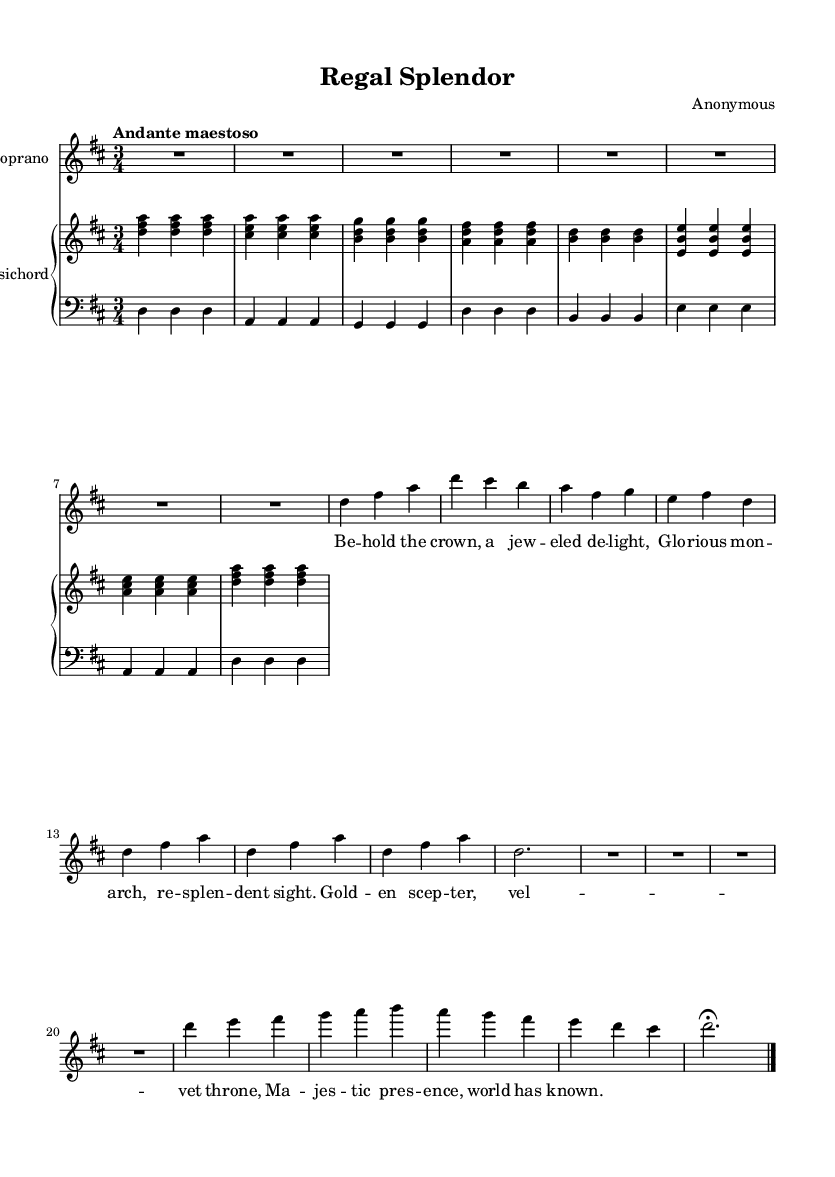What is the key signature of this music? The key signature shows two sharps, which indicates the key of D major where F# and C# are sharp.
Answer: D major What is the time signature of this piece? The time signature is indicated as 3/4, meaning there are three beats in each measure, with the quarter note getting one beat.
Answer: 3/4 What is the tempo of this aria? The tempo marking states "Andante maestoso," which indicates a moderately slow speed with a dignified feeling.
Answer: Andante maestoso How many measures are there in the sheet music? Counting the measures, there are a total of 8 measures presented in the score segment, as indicated by the vertical bar lines separating the measures.
Answer: 8 measures What is the dynamic marking for the soprano voice? The dynamic marking for the soprano voice is "Up," indicating that the singer should project their voice upwards, often used to create emphasis.
Answer: Up What type of accompaniment is used for this aria? The accompaniment consists of a harpsichord with two staves, a right-hand part usually playing chords, and a left-hand bass line providing harmonic support, which is typical for Baroque music.
Answer: Harpsichord What theme is celebrated in the lyrics? The lyrics celebrate the grandeur of monarchy, reflecting the royal qualities and magnificent attributes traditionally associated with monarchs.
Answer: Grandeur of monarchy 